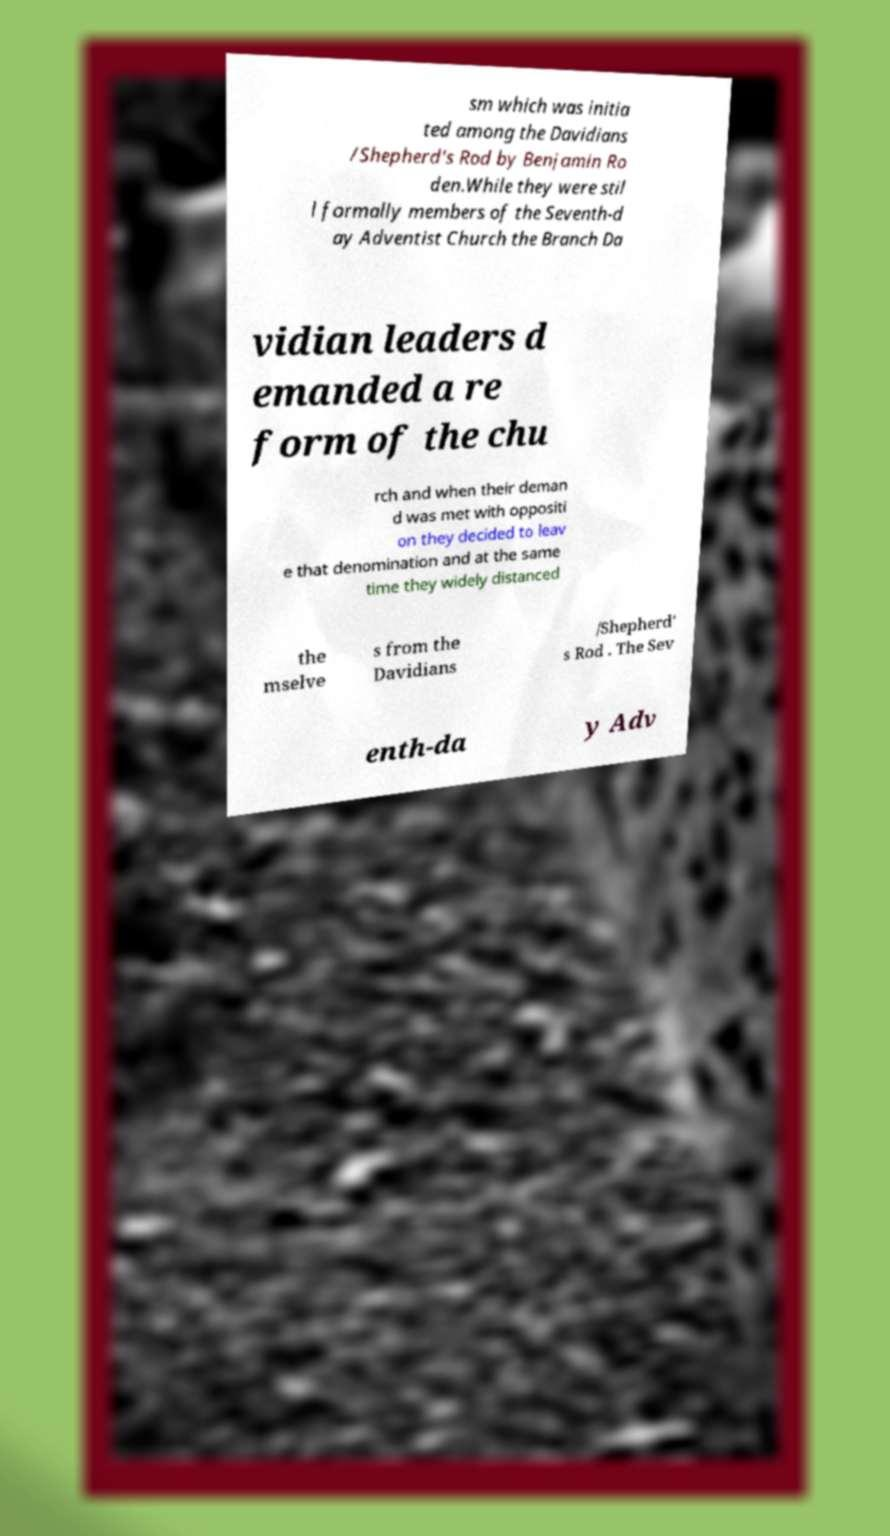Can you read and provide the text displayed in the image?This photo seems to have some interesting text. Can you extract and type it out for me? sm which was initia ted among the Davidians /Shepherd's Rod by Benjamin Ro den.While they were stil l formally members of the Seventh-d ay Adventist Church the Branch Da vidian leaders d emanded a re form of the chu rch and when their deman d was met with oppositi on they decided to leav e that denomination and at the same time they widely distanced the mselve s from the Davidians /Shepherd' s Rod . The Sev enth-da y Adv 